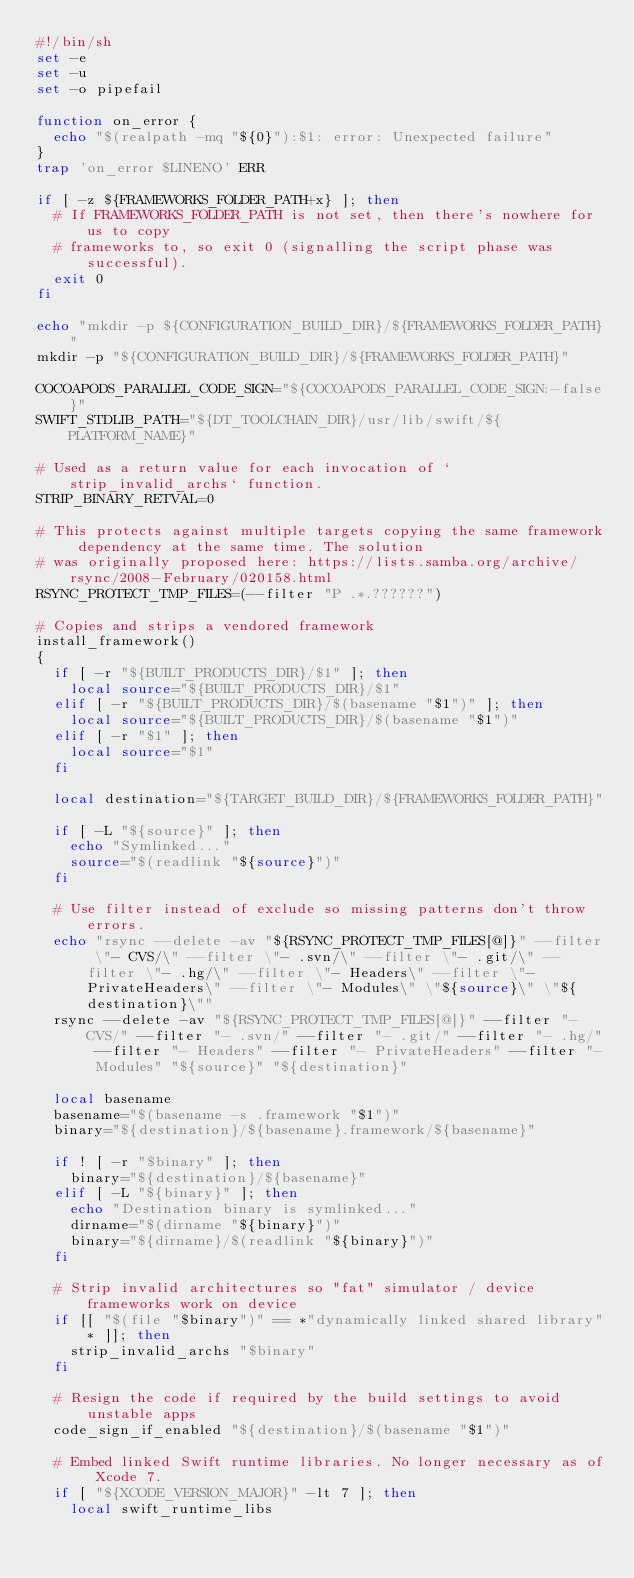<code> <loc_0><loc_0><loc_500><loc_500><_Bash_>#!/bin/sh
set -e
set -u
set -o pipefail

function on_error {
  echo "$(realpath -mq "${0}"):$1: error: Unexpected failure"
}
trap 'on_error $LINENO' ERR

if [ -z ${FRAMEWORKS_FOLDER_PATH+x} ]; then
  # If FRAMEWORKS_FOLDER_PATH is not set, then there's nowhere for us to copy
  # frameworks to, so exit 0 (signalling the script phase was successful).
  exit 0
fi

echo "mkdir -p ${CONFIGURATION_BUILD_DIR}/${FRAMEWORKS_FOLDER_PATH}"
mkdir -p "${CONFIGURATION_BUILD_DIR}/${FRAMEWORKS_FOLDER_PATH}"

COCOAPODS_PARALLEL_CODE_SIGN="${COCOAPODS_PARALLEL_CODE_SIGN:-false}"
SWIFT_STDLIB_PATH="${DT_TOOLCHAIN_DIR}/usr/lib/swift/${PLATFORM_NAME}"

# Used as a return value for each invocation of `strip_invalid_archs` function.
STRIP_BINARY_RETVAL=0

# This protects against multiple targets copying the same framework dependency at the same time. The solution
# was originally proposed here: https://lists.samba.org/archive/rsync/2008-February/020158.html
RSYNC_PROTECT_TMP_FILES=(--filter "P .*.??????")

# Copies and strips a vendored framework
install_framework()
{
  if [ -r "${BUILT_PRODUCTS_DIR}/$1" ]; then
    local source="${BUILT_PRODUCTS_DIR}/$1"
  elif [ -r "${BUILT_PRODUCTS_DIR}/$(basename "$1")" ]; then
    local source="${BUILT_PRODUCTS_DIR}/$(basename "$1")"
  elif [ -r "$1" ]; then
    local source="$1"
  fi

  local destination="${TARGET_BUILD_DIR}/${FRAMEWORKS_FOLDER_PATH}"

  if [ -L "${source}" ]; then
    echo "Symlinked..."
    source="$(readlink "${source}")"
  fi

  # Use filter instead of exclude so missing patterns don't throw errors.
  echo "rsync --delete -av "${RSYNC_PROTECT_TMP_FILES[@]}" --filter \"- CVS/\" --filter \"- .svn/\" --filter \"- .git/\" --filter \"- .hg/\" --filter \"- Headers\" --filter \"- PrivateHeaders\" --filter \"- Modules\" \"${source}\" \"${destination}\""
  rsync --delete -av "${RSYNC_PROTECT_TMP_FILES[@]}" --filter "- CVS/" --filter "- .svn/" --filter "- .git/" --filter "- .hg/" --filter "- Headers" --filter "- PrivateHeaders" --filter "- Modules" "${source}" "${destination}"

  local basename
  basename="$(basename -s .framework "$1")"
  binary="${destination}/${basename}.framework/${basename}"

  if ! [ -r "$binary" ]; then
    binary="${destination}/${basename}"
  elif [ -L "${binary}" ]; then
    echo "Destination binary is symlinked..."
    dirname="$(dirname "${binary}")"
    binary="${dirname}/$(readlink "${binary}")"
  fi

  # Strip invalid architectures so "fat" simulator / device frameworks work on device
  if [[ "$(file "$binary")" == *"dynamically linked shared library"* ]]; then
    strip_invalid_archs "$binary"
  fi

  # Resign the code if required by the build settings to avoid unstable apps
  code_sign_if_enabled "${destination}/$(basename "$1")"

  # Embed linked Swift runtime libraries. No longer necessary as of Xcode 7.
  if [ "${XCODE_VERSION_MAJOR}" -lt 7 ]; then
    local swift_runtime_libs</code> 